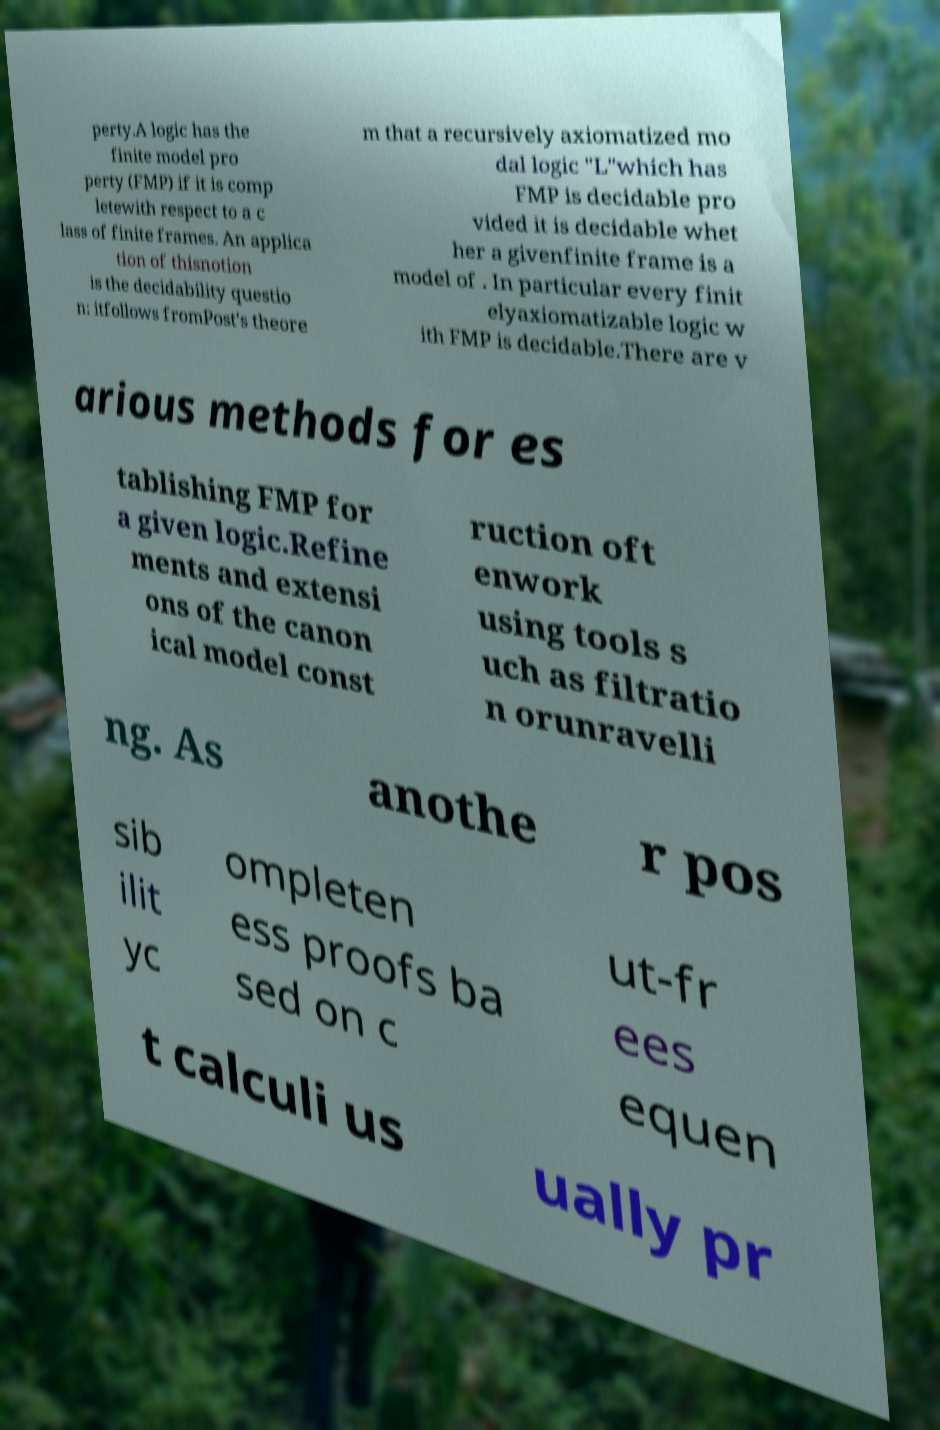Could you extract and type out the text from this image? perty.A logic has the finite model pro perty (FMP) if it is comp letewith respect to a c lass of finite frames. An applica tion of thisnotion is the decidability questio n: itfollows fromPost's theore m that a recursively axiomatized mo dal logic "L"which has FMP is decidable pro vided it is decidable whet her a givenfinite frame is a model of . In particular every finit elyaxiomatizable logic w ith FMP is decidable.There are v arious methods for es tablishing FMP for a given logic.Refine ments and extensi ons of the canon ical model const ruction oft enwork using tools s uch as filtratio n orunravelli ng. As anothe r pos sib ilit yc ompleten ess proofs ba sed on c ut-fr ees equen t calculi us ually pr 